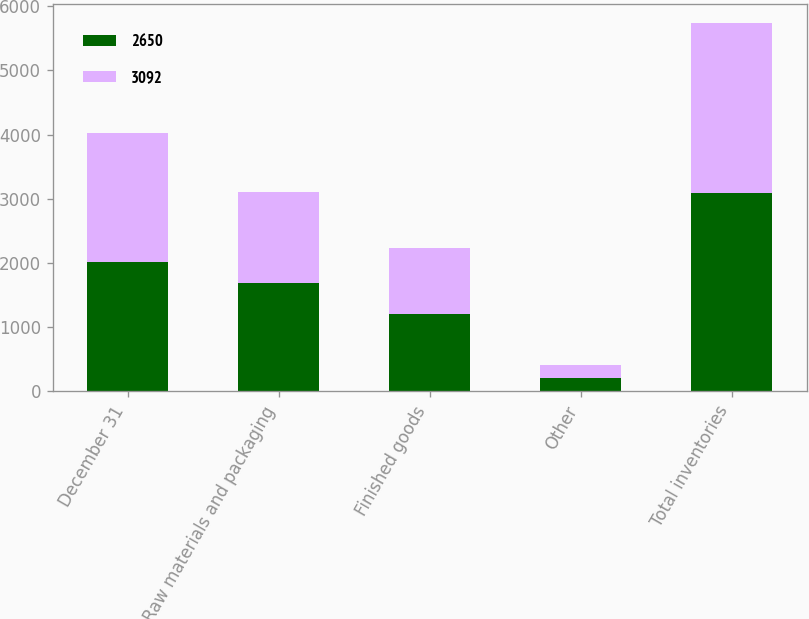<chart> <loc_0><loc_0><loc_500><loc_500><stacked_bar_chart><ecel><fcel>December 31<fcel>Raw materials and packaging<fcel>Finished goods<fcel>Other<fcel>Total inventories<nl><fcel>2650<fcel>2011<fcel>1680<fcel>1198<fcel>214<fcel>3092<nl><fcel>3092<fcel>2010<fcel>1425<fcel>1029<fcel>196<fcel>2650<nl></chart> 